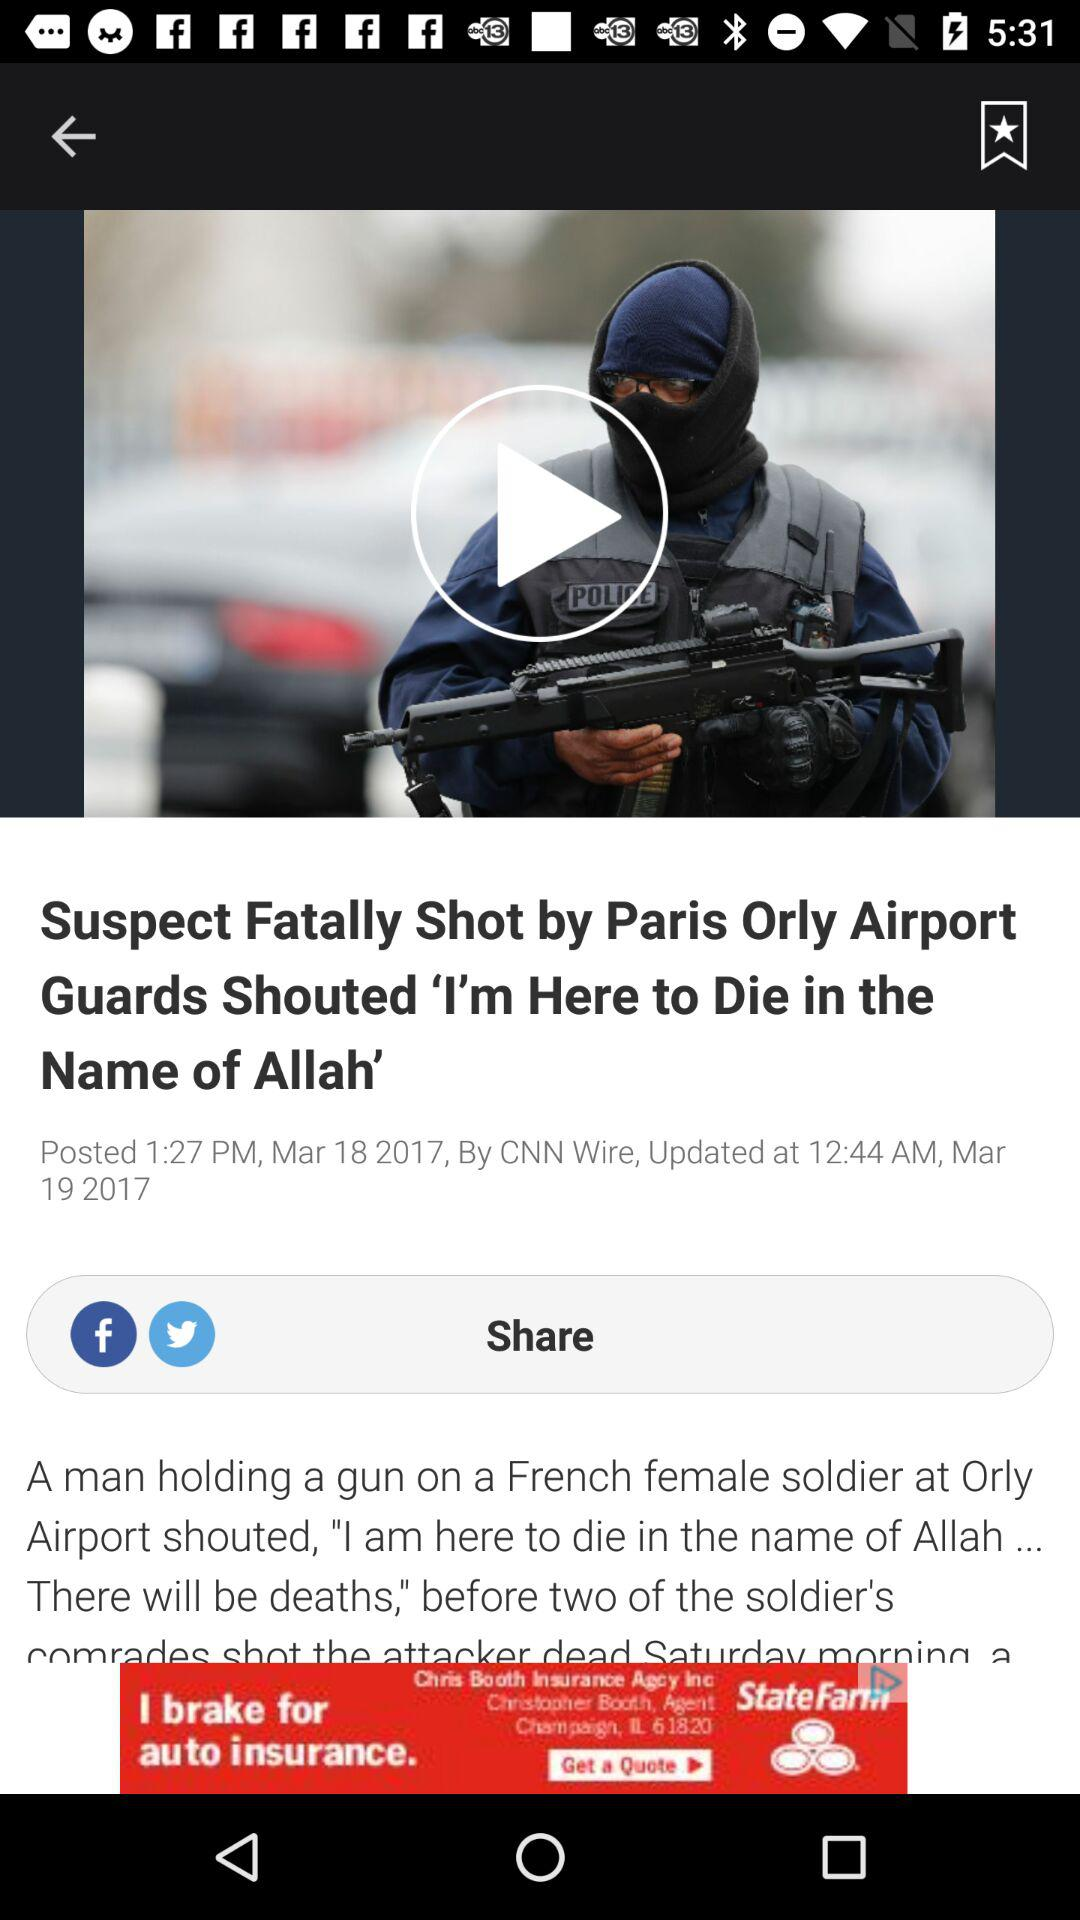What is the posted date of the article? The posted date of the article is March 18, 2017. 